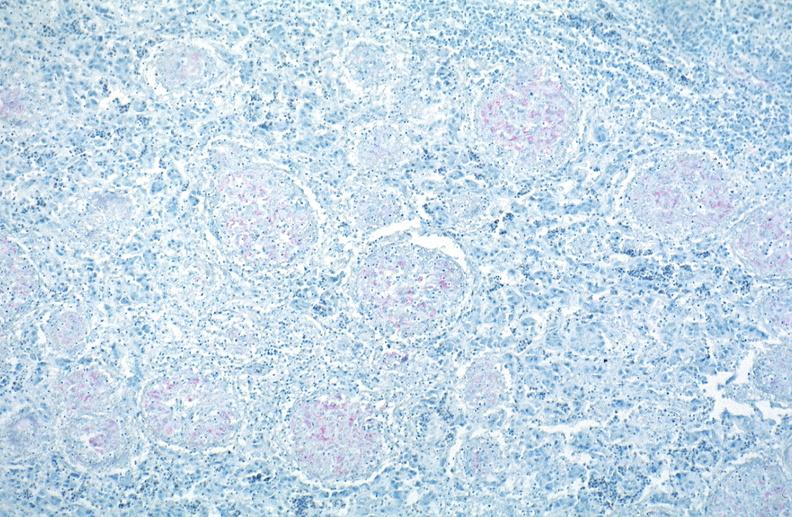s cut surface typical ivory vertebra do not have history at this time diagnosis present?
Answer the question using a single word or phrase. No 